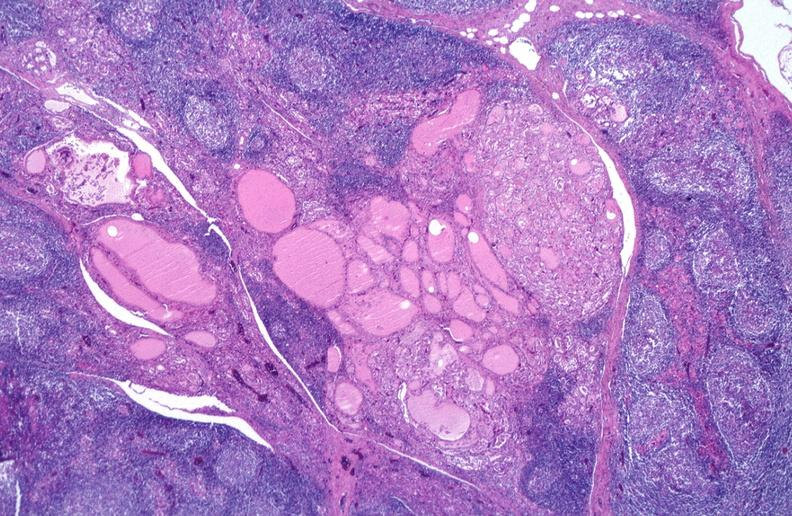does this image show hashimoto 's thyroiditis?
Answer the question using a single word or phrase. Yes 